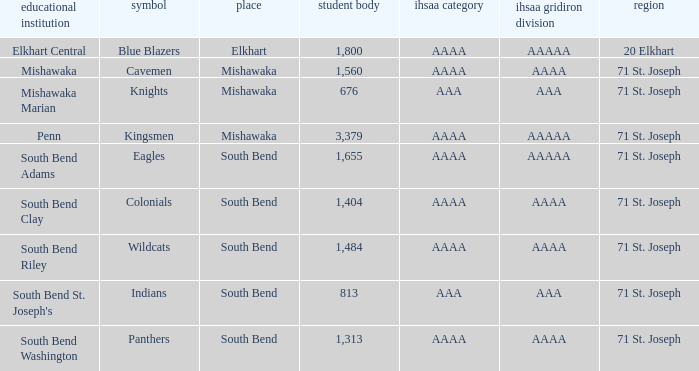What IHSAA Football Class has 20 elkhart as the county? AAAAA. 